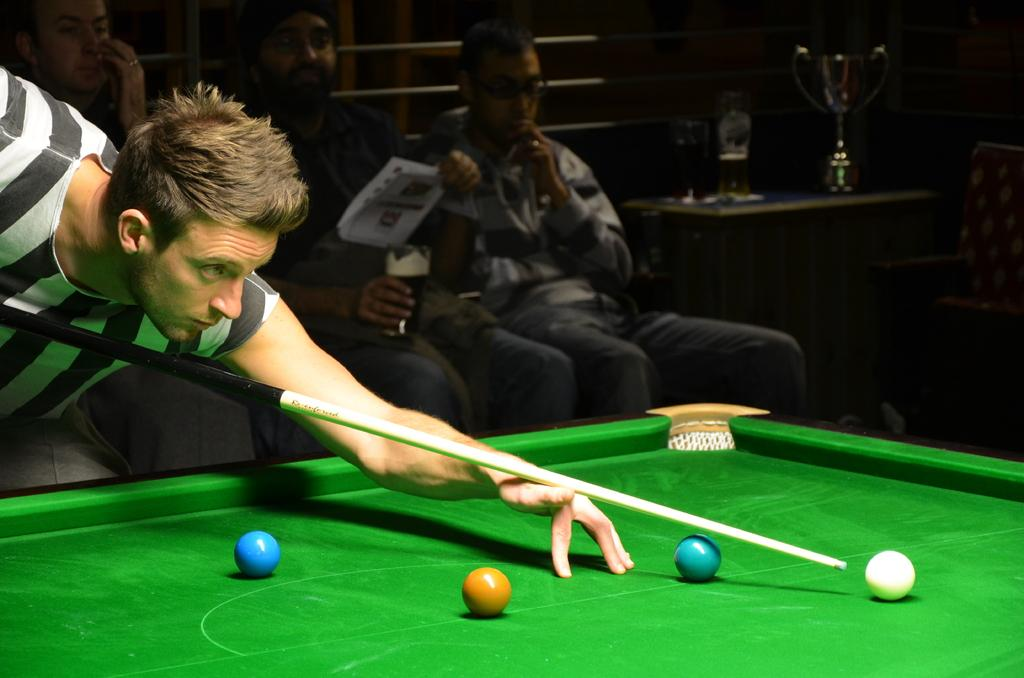What activity is the man in the image engaged in? The man in the image is playing snooker. Are there any other people present in the image? Yes, there are three men sitting behind the man playing snooker. What can be seen on the right side of the image? There is a cup on the right side of the image. How many crackers are on the table in the image? There is no mention of crackers in the image, so we cannot determine their presence or quantity. 